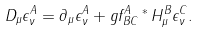<formula> <loc_0><loc_0><loc_500><loc_500>D _ { \mu } \epsilon ^ { A } _ { \nu } = \partial _ { \mu } \epsilon ^ { A } _ { \nu } + g f ^ { A } _ { \, B C } \, ^ { * } \, H ^ { B } _ { \mu } \epsilon ^ { C } _ { \nu } .</formula> 